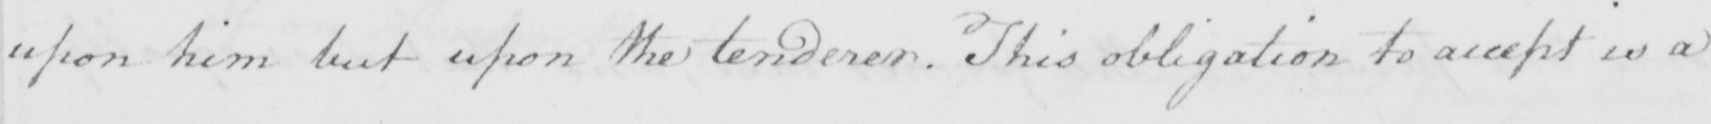What does this handwritten line say? upon him but upon the tenderer . This obligation to accept is a 